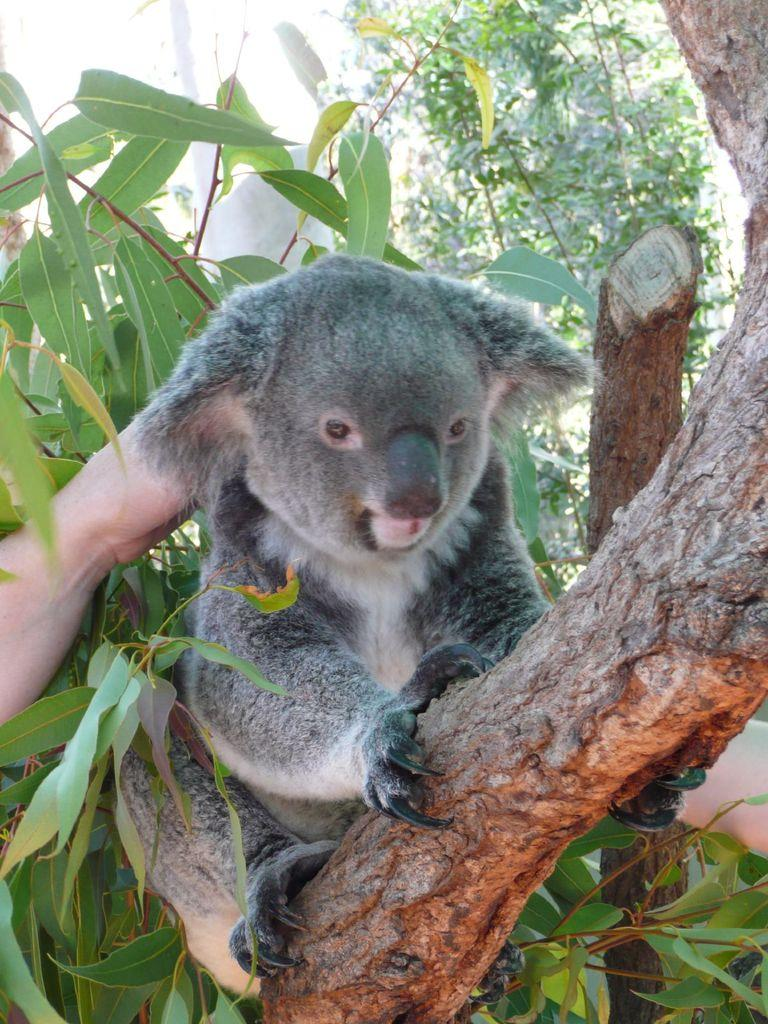What is the animal sitting on in the image? The animal is sitting on a tree in the image. What can be seen on the left and right side of the image? There are people's hands on the left and right side of the image. What type of natural environment is visible in the background of the image? There are trees and a log in the background of the image. What type of quiver is the animal using to store its meal in the image? There is no quiver or meal present in the image; it only features an animal sitting on a tree and people's hands on the sides. 